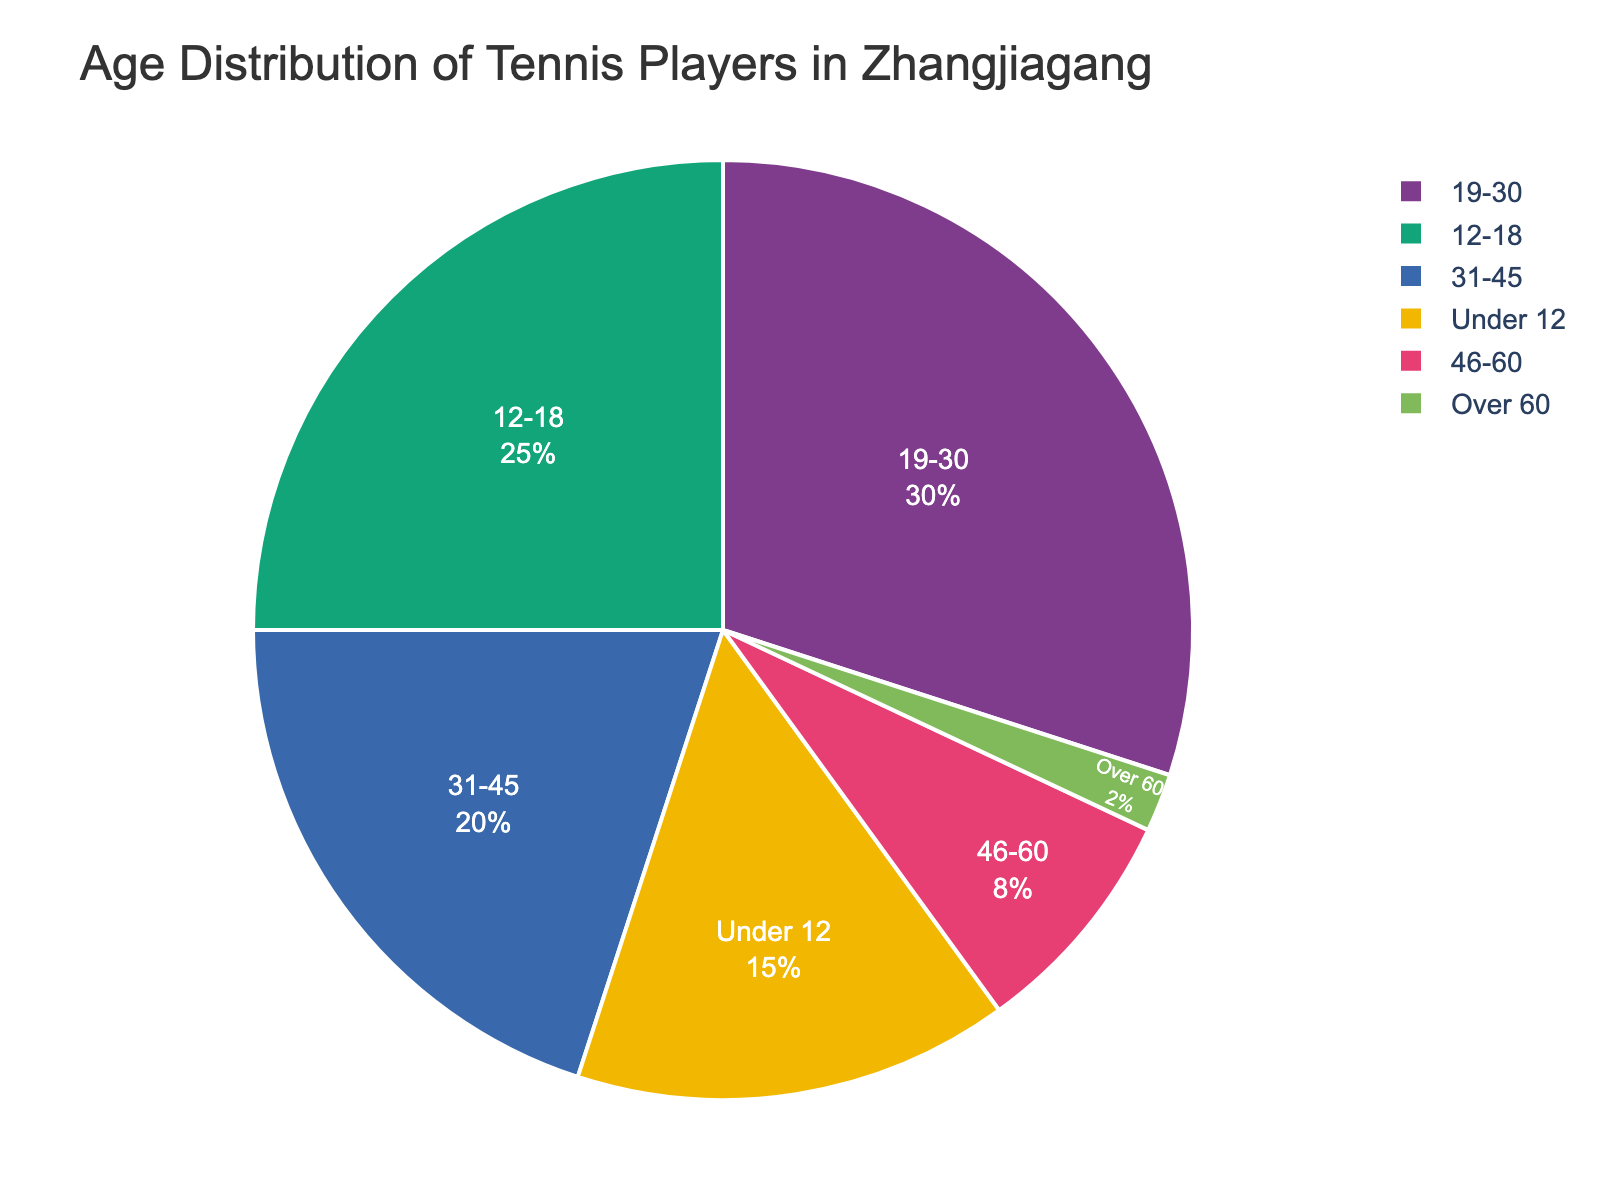What's the most common age group among tennis players in Zhangjiagang? The pie chart shows the age groups and their respective percentages. The largest slice represents the most common age group.
Answer: 19-30 Which age group has the smallest percentage of tennis players? By observing the smallest slice in the pie chart, you can identify the age group with the lowest percentage of players.
Answer: Over 60 How much higher is the percentage of players aged 12-18 compared to those aged 31-45? Subtract the percentage of the 31-45 age group from the percentage of the 12-18 age group: 25% - 20% = 5%
Answer: 5% What is the combined percentage of players aged under 12 and over 60? Add the percentages of the "Under 12" and "Over 60" age groups: 15% + 2% = 17%
Answer: 17% Is the percentage of players aged 46-60 greater than the percentage of those aged over 60? Compare the percentages of the 46-60 age group and the "Over 60" group: 8% > 2%
Answer: Yes Which two age groups have a combined percentage that equals the percentage of the 19-30 age group? Determine which groups add up to 30%: the 12-18 and 46-60 age groups together sum to 25% + 8%; sum of the "Under 12" and 31-45 age groups is 35%. The correct combination is: Under 12 (15%) + 31-45 (20%) = 35% > 30%; 12-18 (25%) + 46-60 (8%) = 33% > 30%, so none fit exactly.
Answer: None What is the difference in percentage between the age groups 19-30 and 31-45? Subtract the percentage of the 31-45 age group from the percentage of the 19-30 age group: 30% - 20% = 10%
Answer: 10% Which age group is represented by the red slice? Based on the color-coded segments in the pie chart, identify which age group corresponds to the red area. This identification depends on careful observation or legend information.
Answer: (Varies depending on the color coding used) Is it true that the sum of the percentages of the age groups Under 12, 31-45, and Over 60 is less than the percentage of the 19-30 age group? Add the percentages: 15% (Under 12) + 20% (31-45) + 2% (Over 60) = 37%. Since 37% is greater than 30% (19-30), the statement is false.
Answer: No 